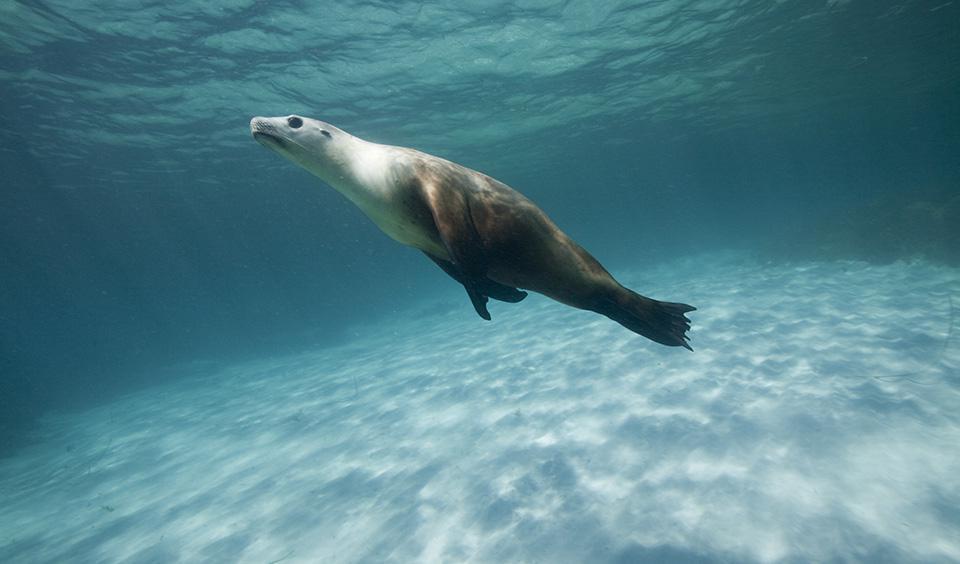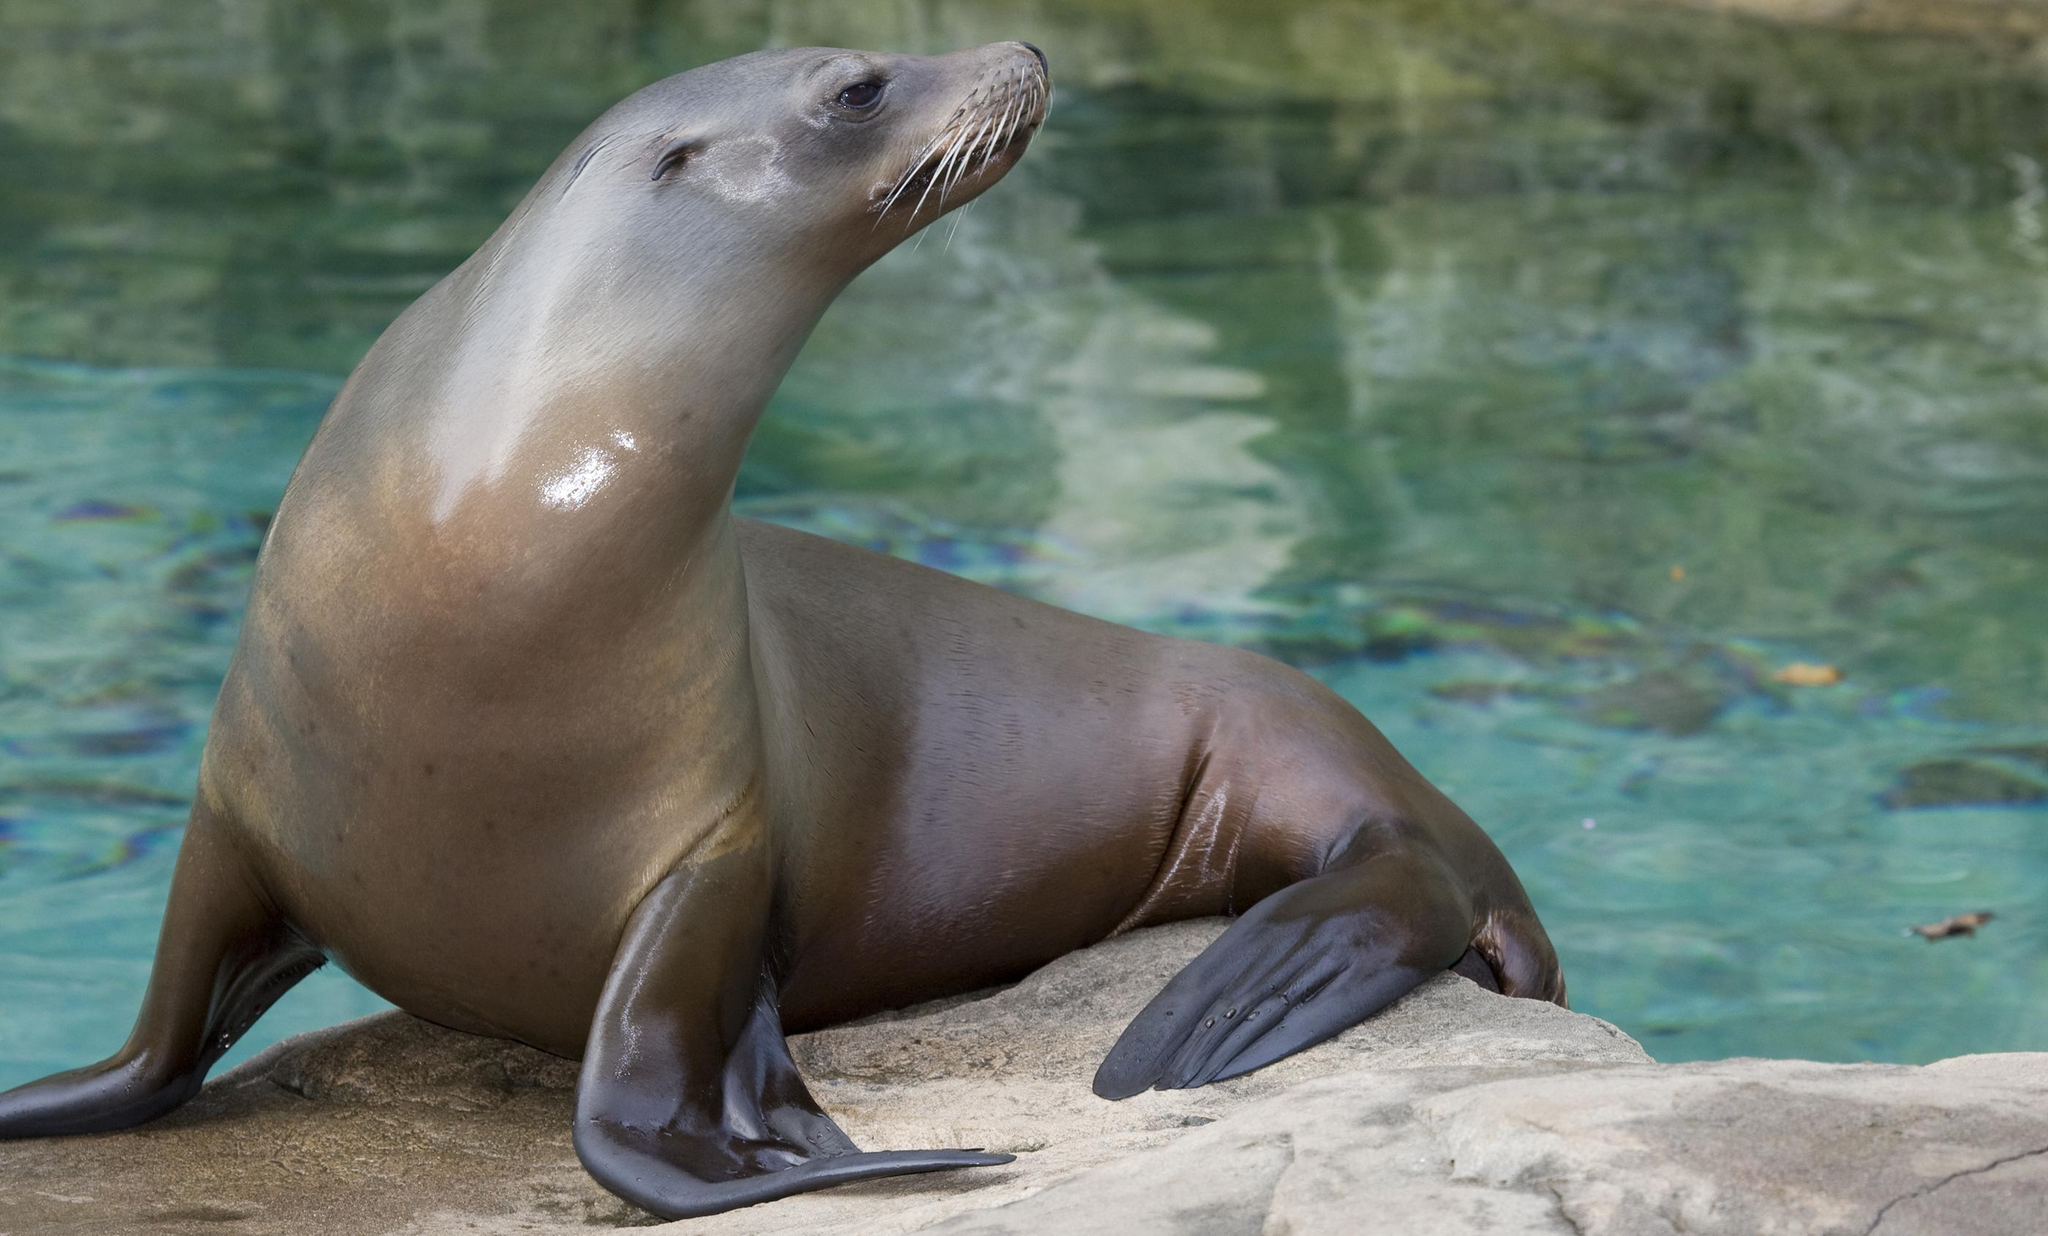The first image is the image on the left, the second image is the image on the right. For the images displayed, is the sentence "There is no less than one seal swimming underwater" factually correct? Answer yes or no. Yes. The first image is the image on the left, the second image is the image on the right. Examine the images to the left and right. Is the description "There are seals underwater" accurate? Answer yes or no. Yes. 